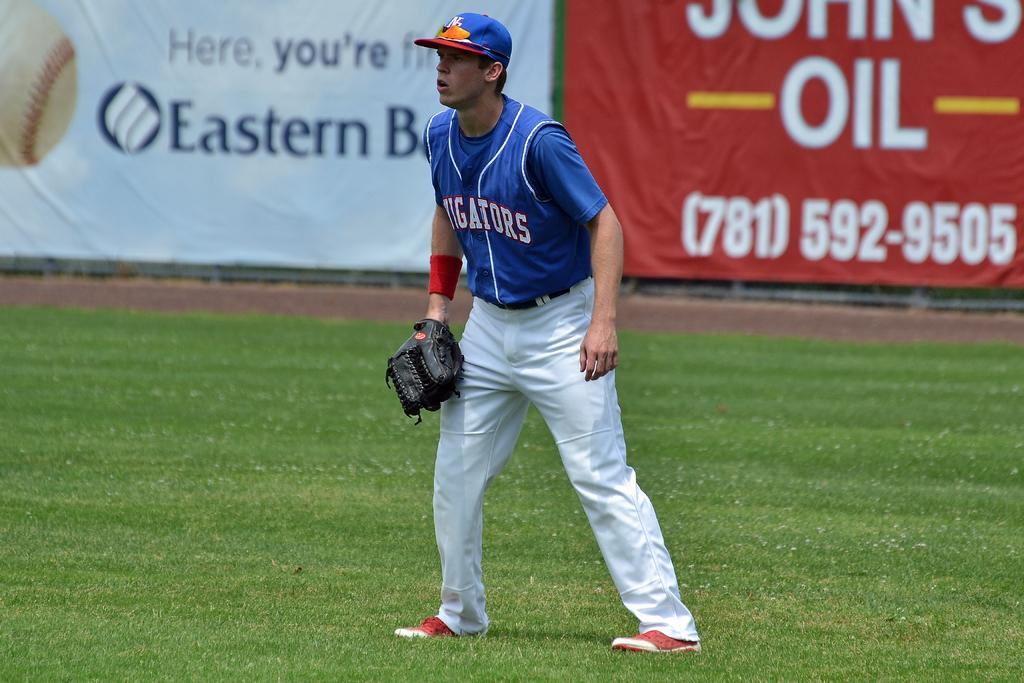Who or what is present in the image? There is a person in the image. What protective gear is the person wearing? The person is wearing a helmet. What other accessory is the person wearing? The person is wearing a glove. What can be seen in the background of the image? There are banners and grass in the background of the image. What type of needle is being used by the person in the image? There is no needle present in the image. The person is wearing a helmet and a glove, but there is no indication of a needle being used. 